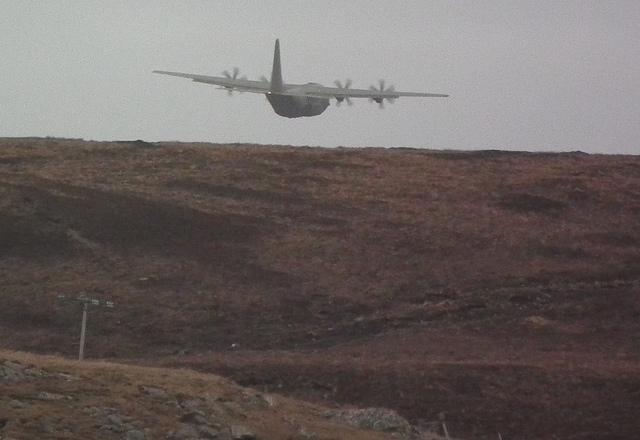Are the propellers in motion?
Concise answer only. Yes. Is this plane taking off or landing?
Concise answer only. Taking off. Is the sky cloudy or clear?
Be succinct. Cloudy. How many planes are depicted?
Be succinct. 1. Is the plane flying over a desert?
Answer briefly. Yes. What continent is this plane flying over?
Answer briefly. North america. What is on the ground?
Short answer required. Dirt. Is there are house nearby?
Keep it brief. No. 